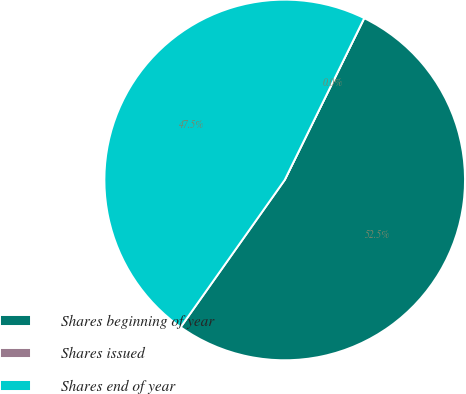<chart> <loc_0><loc_0><loc_500><loc_500><pie_chart><fcel>Shares beginning of year<fcel>Shares issued<fcel>Shares end of year<nl><fcel>52.52%<fcel>0.0%<fcel>47.47%<nl></chart> 